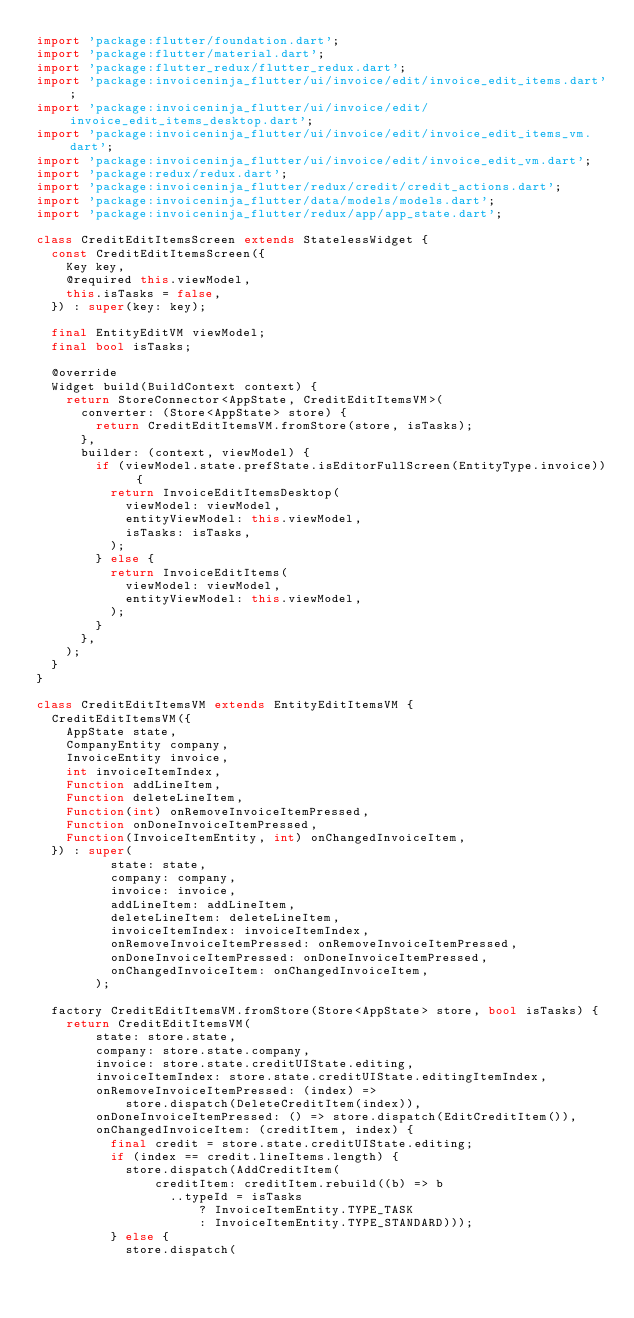<code> <loc_0><loc_0><loc_500><loc_500><_Dart_>import 'package:flutter/foundation.dart';
import 'package:flutter/material.dart';
import 'package:flutter_redux/flutter_redux.dart';
import 'package:invoiceninja_flutter/ui/invoice/edit/invoice_edit_items.dart';
import 'package:invoiceninja_flutter/ui/invoice/edit/invoice_edit_items_desktop.dart';
import 'package:invoiceninja_flutter/ui/invoice/edit/invoice_edit_items_vm.dart';
import 'package:invoiceninja_flutter/ui/invoice/edit/invoice_edit_vm.dart';
import 'package:redux/redux.dart';
import 'package:invoiceninja_flutter/redux/credit/credit_actions.dart';
import 'package:invoiceninja_flutter/data/models/models.dart';
import 'package:invoiceninja_flutter/redux/app/app_state.dart';

class CreditEditItemsScreen extends StatelessWidget {
  const CreditEditItemsScreen({
    Key key,
    @required this.viewModel,
    this.isTasks = false,
  }) : super(key: key);

  final EntityEditVM viewModel;
  final bool isTasks;

  @override
  Widget build(BuildContext context) {
    return StoreConnector<AppState, CreditEditItemsVM>(
      converter: (Store<AppState> store) {
        return CreditEditItemsVM.fromStore(store, isTasks);
      },
      builder: (context, viewModel) {
        if (viewModel.state.prefState.isEditorFullScreen(EntityType.invoice)) {
          return InvoiceEditItemsDesktop(
            viewModel: viewModel,
            entityViewModel: this.viewModel,
            isTasks: isTasks,
          );
        } else {
          return InvoiceEditItems(
            viewModel: viewModel,
            entityViewModel: this.viewModel,
          );
        }
      },
    );
  }
}

class CreditEditItemsVM extends EntityEditItemsVM {
  CreditEditItemsVM({
    AppState state,
    CompanyEntity company,
    InvoiceEntity invoice,
    int invoiceItemIndex,
    Function addLineItem,
    Function deleteLineItem,
    Function(int) onRemoveInvoiceItemPressed,
    Function onDoneInvoiceItemPressed,
    Function(InvoiceItemEntity, int) onChangedInvoiceItem,
  }) : super(
          state: state,
          company: company,
          invoice: invoice,
          addLineItem: addLineItem,
          deleteLineItem: deleteLineItem,
          invoiceItemIndex: invoiceItemIndex,
          onRemoveInvoiceItemPressed: onRemoveInvoiceItemPressed,
          onDoneInvoiceItemPressed: onDoneInvoiceItemPressed,
          onChangedInvoiceItem: onChangedInvoiceItem,
        );

  factory CreditEditItemsVM.fromStore(Store<AppState> store, bool isTasks) {
    return CreditEditItemsVM(
        state: store.state,
        company: store.state.company,
        invoice: store.state.creditUIState.editing,
        invoiceItemIndex: store.state.creditUIState.editingItemIndex,
        onRemoveInvoiceItemPressed: (index) =>
            store.dispatch(DeleteCreditItem(index)),
        onDoneInvoiceItemPressed: () => store.dispatch(EditCreditItem()),
        onChangedInvoiceItem: (creditItem, index) {
          final credit = store.state.creditUIState.editing;
          if (index == credit.lineItems.length) {
            store.dispatch(AddCreditItem(
                creditItem: creditItem.rebuild((b) => b
                  ..typeId = isTasks
                      ? InvoiceItemEntity.TYPE_TASK
                      : InvoiceItemEntity.TYPE_STANDARD)));
          } else {
            store.dispatch(</code> 